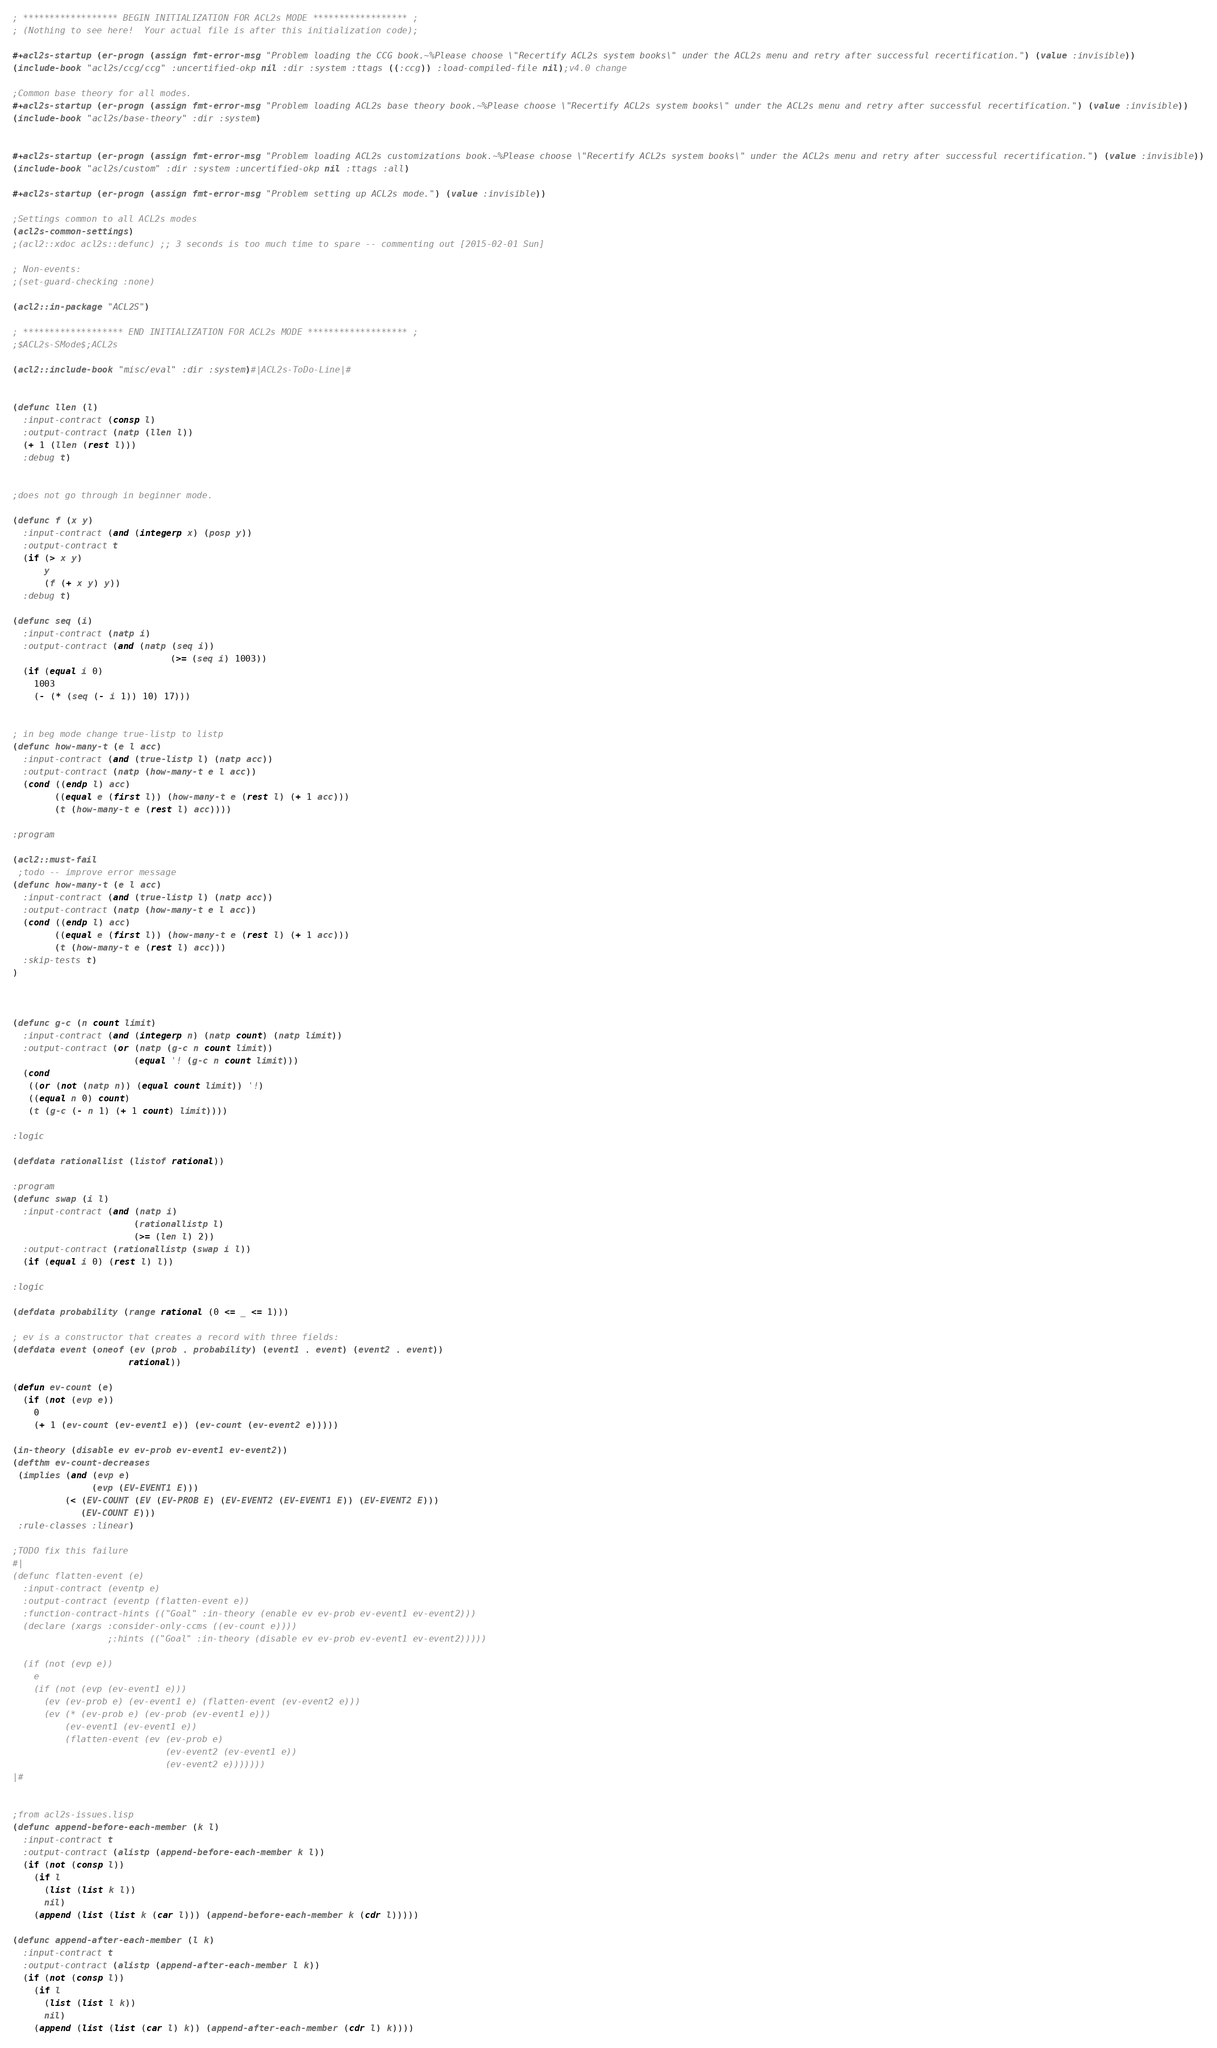Convert code to text. <code><loc_0><loc_0><loc_500><loc_500><_Lisp_>; ****************** BEGIN INITIALIZATION FOR ACL2s MODE ****************** ;
; (Nothing to see here!  Your actual file is after this initialization code);

#+acl2s-startup (er-progn (assign fmt-error-msg "Problem loading the CCG book.~%Please choose \"Recertify ACL2s system books\" under the ACL2s menu and retry after successful recertification.") (value :invisible))
(include-book "acl2s/ccg/ccg" :uncertified-okp nil :dir :system :ttags ((:ccg)) :load-compiled-file nil);v4.0 change

;Common base theory for all modes.
#+acl2s-startup (er-progn (assign fmt-error-msg "Problem loading ACL2s base theory book.~%Please choose \"Recertify ACL2s system books\" under the ACL2s menu and retry after successful recertification.") (value :invisible))
(include-book "acl2s/base-theory" :dir :system)


#+acl2s-startup (er-progn (assign fmt-error-msg "Problem loading ACL2s customizations book.~%Please choose \"Recertify ACL2s system books\" under the ACL2s menu and retry after successful recertification.") (value :invisible))
(include-book "acl2s/custom" :dir :system :uncertified-okp nil :ttags :all)

#+acl2s-startup (er-progn (assign fmt-error-msg "Problem setting up ACL2s mode.") (value :invisible))

;Settings common to all ACL2s modes
(acl2s-common-settings)
;(acl2::xdoc acl2s::defunc) ;; 3 seconds is too much time to spare -- commenting out [2015-02-01 Sun]

; Non-events:
;(set-guard-checking :none)

(acl2::in-package "ACL2S")

; ******************* END INITIALIZATION FOR ACL2s MODE ******************* ;
;$ACL2s-SMode$;ACL2s

(acl2::include-book "misc/eval" :dir :system)#|ACL2s-ToDo-Line|#


(defunc llen (l)
  :input-contract (consp l)
  :output-contract (natp (llen l))
  (+ 1 (llen (rest l)))
  :debug t)


;does not go through in beginner mode.

(defunc f (x y)
  :input-contract (and (integerp x) (posp y))
  :output-contract t
  (if (> x y)
      y
      (f (+ x y) y))
  :debug t)

(defunc seq (i)
  :input-contract (natp i)
  :output-contract (and (natp (seq i))
                              (>= (seq i) 1003))
  (if (equal i 0)
    1003
    (- (* (seq (- i 1)) 10) 17)))


; in beg mode change true-listp to listp
(defunc how-many-t (e l acc)
  :input-contract (and (true-listp l) (natp acc))
  :output-contract (natp (how-many-t e l acc))
  (cond ((endp l) acc)
        ((equal e (first l)) (how-many-t e (rest l) (+ 1 acc)))
        (t (how-many-t e (rest l) acc))))

:program

(acl2::must-fail
 ;todo -- improve error message
(defunc how-many-t (e l acc)
  :input-contract (and (true-listp l) (natp acc))
  :output-contract (natp (how-many-t e l acc))
  (cond ((endp l) acc)
        ((equal e (first l)) (how-many-t e (rest l) (+ 1 acc)))
        (t (how-many-t e (rest l) acc)))
  :skip-tests t)
)



(defunc g-c (n count limit)
  :input-contract (and (integerp n) (natp count) (natp limit))
  :output-contract (or (natp (g-c n count limit))
                       (equal '! (g-c n count limit)))
  (cond
   ((or (not (natp n)) (equal count limit)) '!)
   ((equal n 0) count)
   (t (g-c (- n 1) (+ 1 count) limit))))

:logic

(defdata rationallist (listof rational))

:program
(defunc swap (i l)
  :input-contract (and (natp i)
                       (rationallistp l)
                       (>= (len l) 2))
  :output-contract (rationallistp (swap i l))
  (if (equal i 0) (rest l) l))

:logic

(defdata probability (range rational (0 <= _ <= 1)))

; ev is a constructor that creates a record with three fields:
(defdata event (oneof (ev (prob . probability) (event1 . event) (event2 . event))
                      rational))

(defun ev-count (e)
  (if (not (evp e))
    0
    (+ 1 (ev-count (ev-event1 e)) (ev-count (ev-event2 e)))))
  
(in-theory (disable ev ev-prob ev-event1 ev-event2))
(defthm ev-count-decreases 
 (implies (and (evp e)
               (evp (EV-EVENT1 E)))
          (< (EV-COUNT (EV (EV-PROB E) (EV-EVENT2 (EV-EVENT1 E)) (EV-EVENT2 E)))
             (EV-COUNT E)))
 :rule-classes :linear)

;TODO fix this failure
#|
(defunc flatten-event (e)
  :input-contract (eventp e)
  :output-contract (eventp (flatten-event e))
  :function-contract-hints (("Goal" :in-theory (enable ev ev-prob ev-event1 ev-event2)))
  (declare (xargs :consider-only-ccms ((ev-count e))))
                  ;:hints (("Goal" :in-theory (disable ev ev-prob ev-event1 ev-event2)))))
  
  (if (not (evp e))
    e
    (if (not (evp (ev-event1 e)))
      (ev (ev-prob e) (ev-event1 e) (flatten-event (ev-event2 e)))
      (ev (* (ev-prob e) (ev-prob (ev-event1 e)))
          (ev-event1 (ev-event1 e))
          (flatten-event (ev (ev-prob e)
                             (ev-event2 (ev-event1 e))
                             (ev-event2 e)))))))
|#


;from acl2s-issues.lisp
(defunc append-before-each-member (k l)
  :input-contract t
  :output-contract (alistp (append-before-each-member k l))
  (if (not (consp l))
    (if l
      (list (list k l))
      nil)
    (append (list (list k (car l))) (append-before-each-member k (cdr l)))))

(defunc append-after-each-member (l k)
  :input-contract t
  :output-contract (alistp (append-after-each-member l k))
  (if (not (consp l))
    (if l
      (list (list l k))
      nil)
    (append (list (list (car l) k)) (append-after-each-member (cdr l) k))))
</code> 